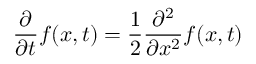<formula> <loc_0><loc_0><loc_500><loc_500>{ \frac { \partial } { \partial t } } f ( x , t ) = { \frac { 1 } { 2 } } { \frac { \partial ^ { 2 } } { \partial x ^ { 2 } } } f ( x , t )</formula> 